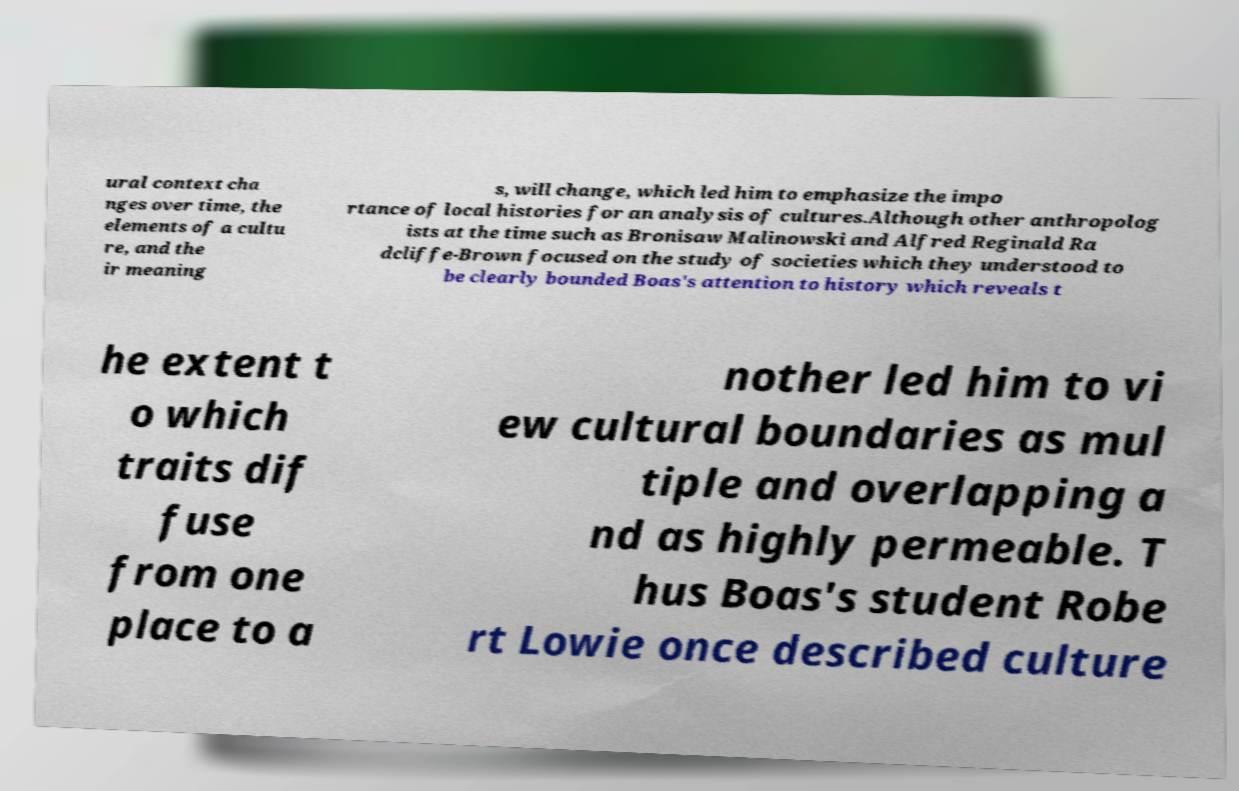For documentation purposes, I need the text within this image transcribed. Could you provide that? ural context cha nges over time, the elements of a cultu re, and the ir meaning s, will change, which led him to emphasize the impo rtance of local histories for an analysis of cultures.Although other anthropolog ists at the time such as Bronisaw Malinowski and Alfred Reginald Ra dcliffe-Brown focused on the study of societies which they understood to be clearly bounded Boas's attention to history which reveals t he extent t o which traits dif fuse from one place to a nother led him to vi ew cultural boundaries as mul tiple and overlapping a nd as highly permeable. T hus Boas's student Robe rt Lowie once described culture 